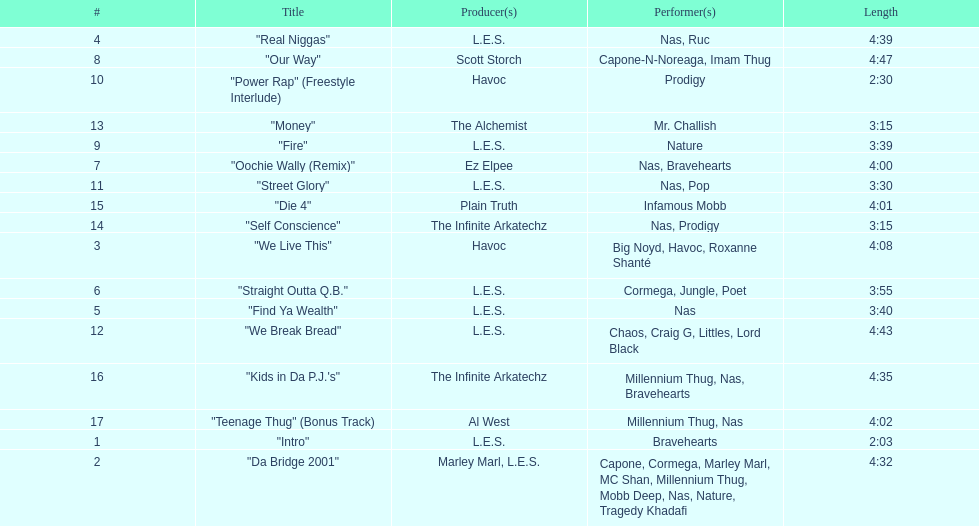What is the name of the last song on the album? "Teenage Thug" (Bonus Track). 